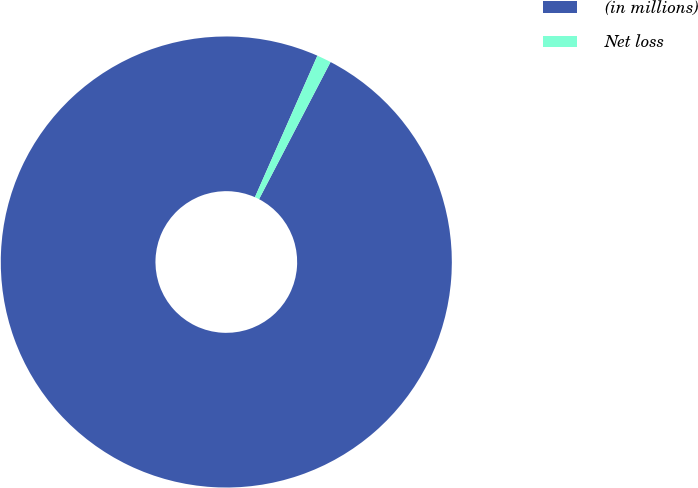Convert chart. <chart><loc_0><loc_0><loc_500><loc_500><pie_chart><fcel>(in millions)<fcel>Net loss<nl><fcel>98.97%<fcel>1.03%<nl></chart> 